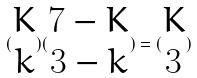Convert formula to latex. <formula><loc_0><loc_0><loc_500><loc_500>( \begin{matrix} K \\ k \end{matrix} ) ( \begin{matrix} 7 - K \\ 3 - k \end{matrix} ) = ( \begin{matrix} K \\ 3 \end{matrix} )</formula> 